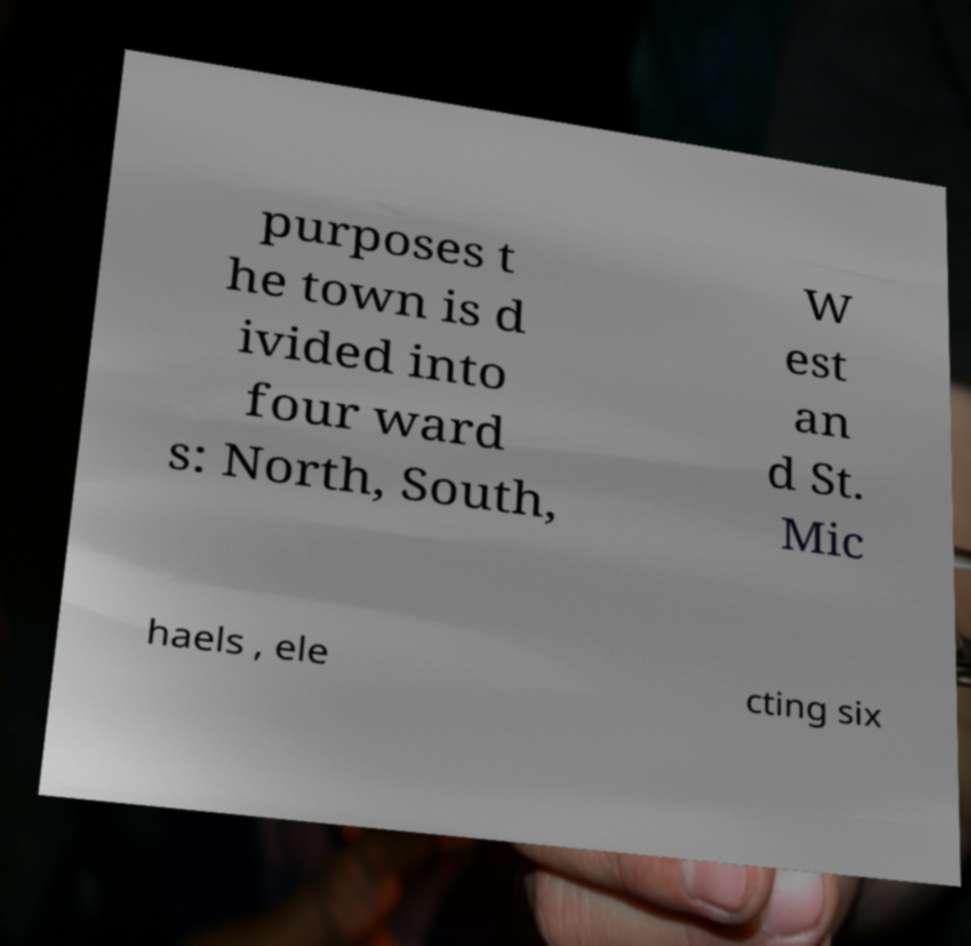Can you read and provide the text displayed in the image?This photo seems to have some interesting text. Can you extract and type it out for me? purposes t he town is d ivided into four ward s: North, South, W est an d St. Mic haels , ele cting six 